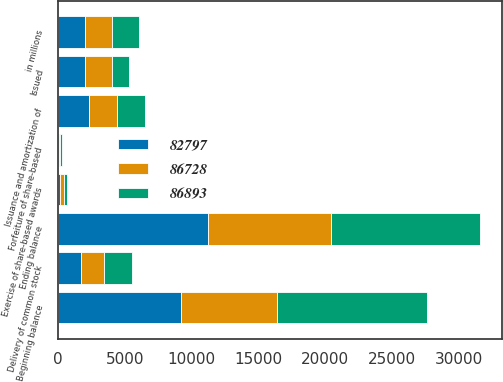<chart> <loc_0><loc_0><loc_500><loc_500><stacked_bar_chart><ecel><fcel>in millions<fcel>Beginning balance<fcel>Issued<fcel>Ending balance<fcel>Issuance and amortization of<fcel>Delivery of common stock<fcel>Forfeiture of share-based<fcel>Exercise of share-based awards<nl><fcel>86893<fcel>2016<fcel>11200<fcel>1325<fcel>11203<fcel>2143<fcel>2068<fcel>102<fcel>210<nl><fcel>82797<fcel>2015<fcel>9200<fcel>2000<fcel>11200<fcel>2308<fcel>1742<fcel>72<fcel>109<nl><fcel>86728<fcel>2014<fcel>7200<fcel>2000<fcel>9200<fcel>2079<fcel>1725<fcel>92<fcel>335<nl></chart> 